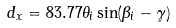<formula> <loc_0><loc_0><loc_500><loc_500>d _ { x } = 8 3 . 7 7 \theta _ { i } \sin ( \beta _ { i } - \gamma )</formula> 